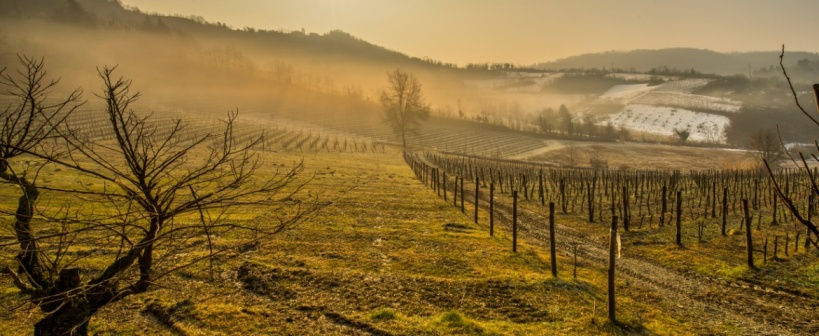Analyze the image in a comprehensive and detailed manner. This image captures the serene beauty of a vineyard gracefully draped across a gently rolling landscape. The vineyard, seen here in a dormant state with bare grapevines arranged in meticulous rows, promises a sense of order and rhythm that is soothing to the eye. The early morning sunlight bathes the scene in a golden hue, highlighting the delicate frost that coats the ground and vines, suggesting a crisp chill in the air. A gentle mist shrouds the distant hills, adding an element of mystery and enchantment to the panorama. This scene is not just a testament to viticulture but also invites contemplation of the cyclical nature of growth and dormancy in vineyards, reflecting broader themes of renewal and patience. 